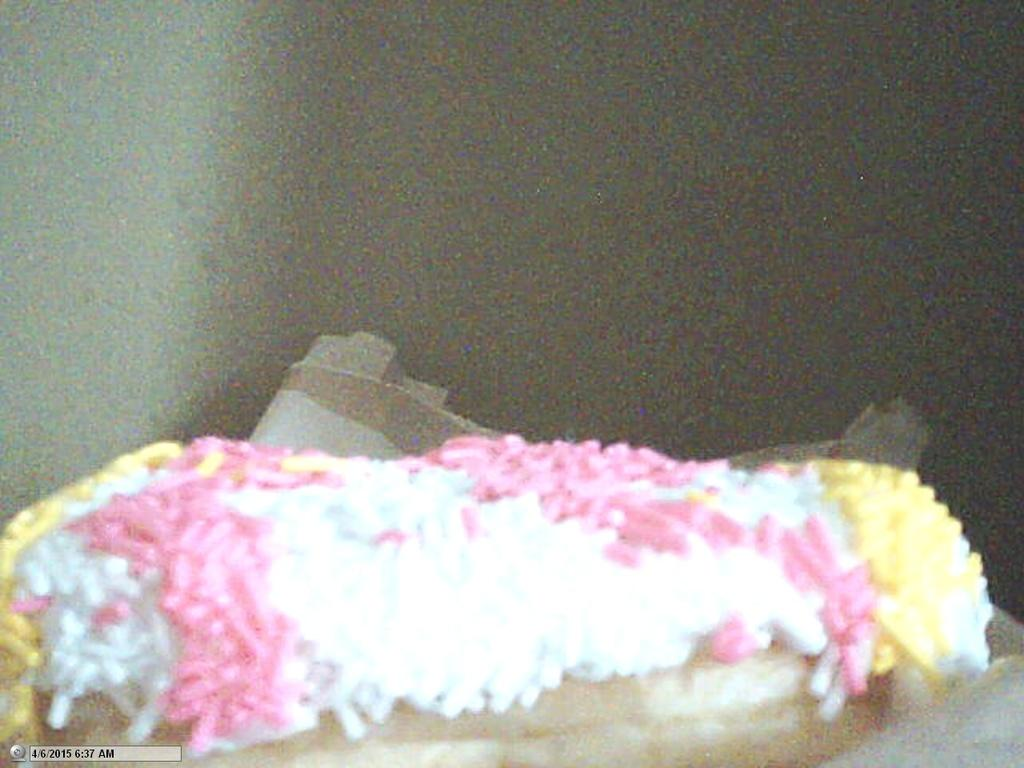What type of food is present in the image? There is a doughnut in the image. What type of punishment is being depicted in the image? There is no punishment being depicted in the image; it features a doughnut. Who is the creator of the doughnut in the image? The creator of the doughnut is not visible or identifiable in the image. 